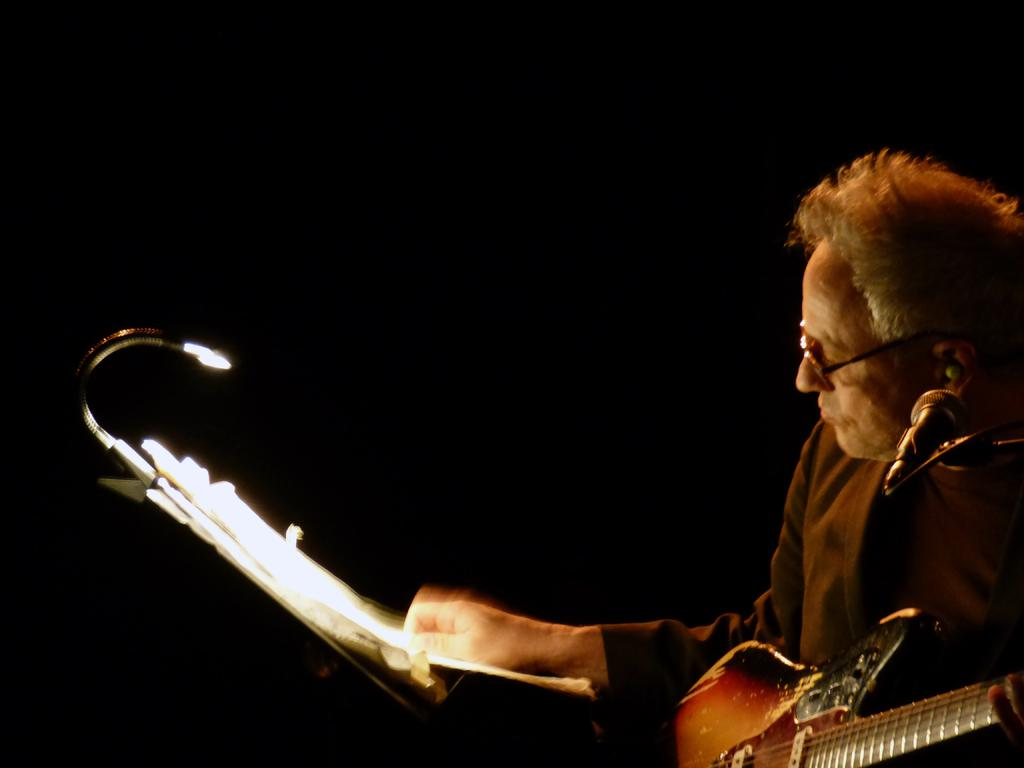What is the man in the image holding? The man is holding a guitar. What object is the man standing in front of? The man is standing in front of a microphone. What type of cow can be seen in the image? There is no cow present in the image. Is there an advertisement visible in the image? There is no advertisement present in the image. 